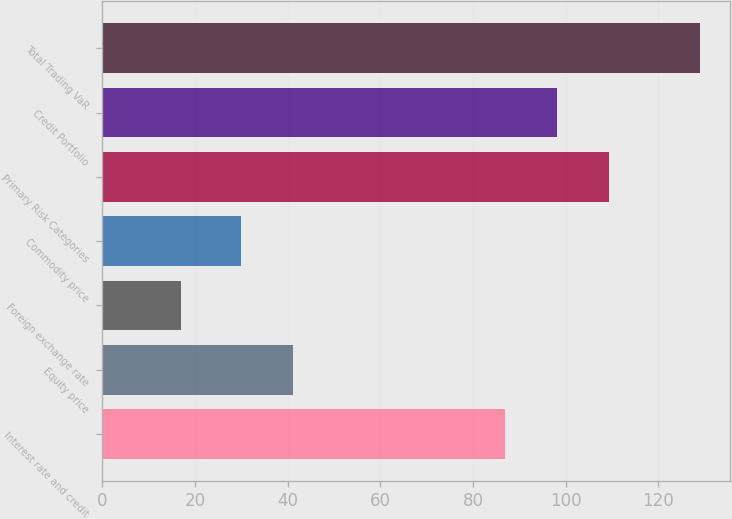Convert chart. <chart><loc_0><loc_0><loc_500><loc_500><bar_chart><fcel>Interest rate and credit<fcel>Equity price<fcel>Foreign exchange rate<fcel>Commodity price<fcel>Primary Risk Categories<fcel>Credit Portfolio<fcel>Total Trading VaR<nl><fcel>87<fcel>41.2<fcel>17<fcel>30<fcel>109.4<fcel>98.2<fcel>129<nl></chart> 